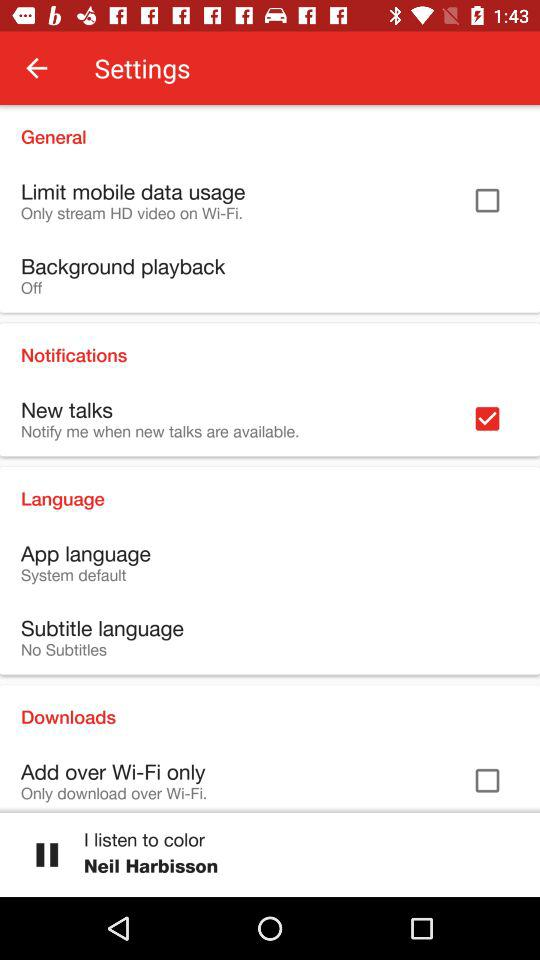What's the setting for the subtitle language? The setting for the subtitle language is "No Subtitles". 